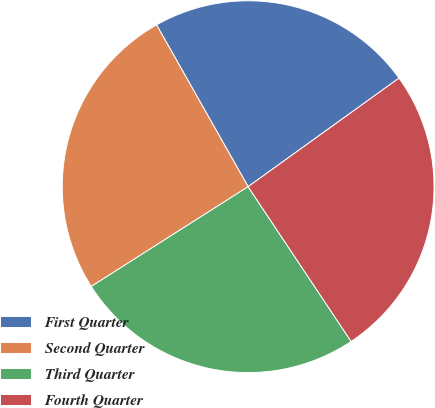Convert chart to OTSL. <chart><loc_0><loc_0><loc_500><loc_500><pie_chart><fcel>First Quarter<fcel>Second Quarter<fcel>Third Quarter<fcel>Fourth Quarter<nl><fcel>23.27%<fcel>25.82%<fcel>25.33%<fcel>25.58%<nl></chart> 